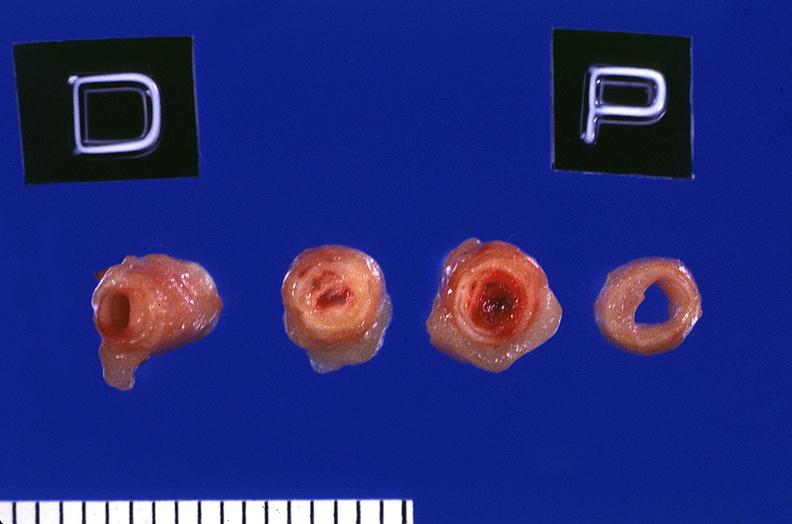s macerated stillborn present?
Answer the question using a single word or phrase. No 